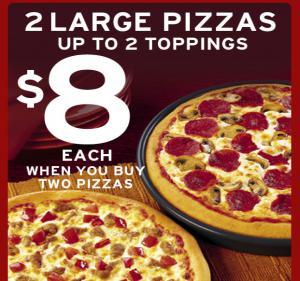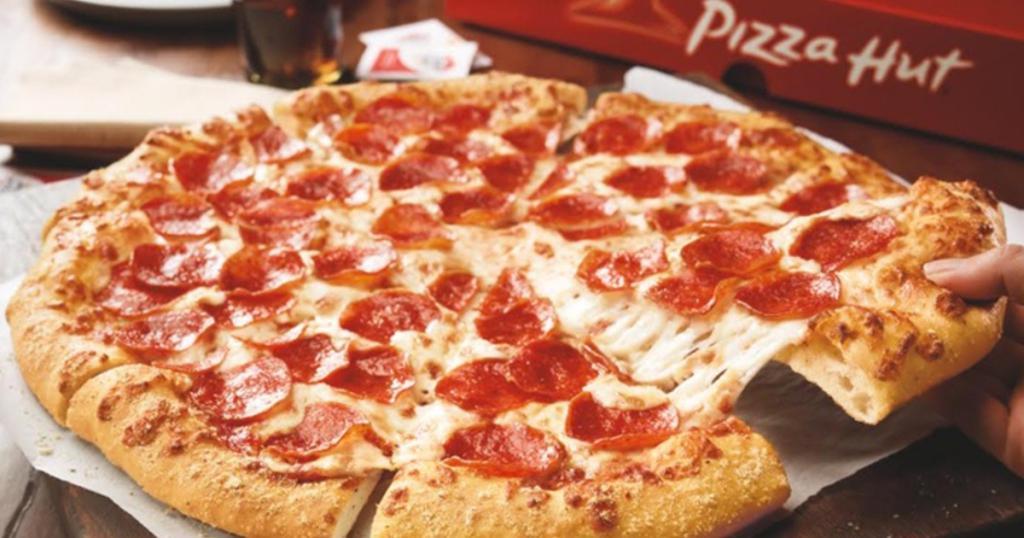The first image is the image on the left, the second image is the image on the right. Given the left and right images, does the statement "There are more pizzas in the image on the left." hold true? Answer yes or no. Yes. The first image is the image on the left, the second image is the image on the right. For the images displayed, is the sentence "Exactly one pizza contains pepperoni." factually correct? Answer yes or no. No. 